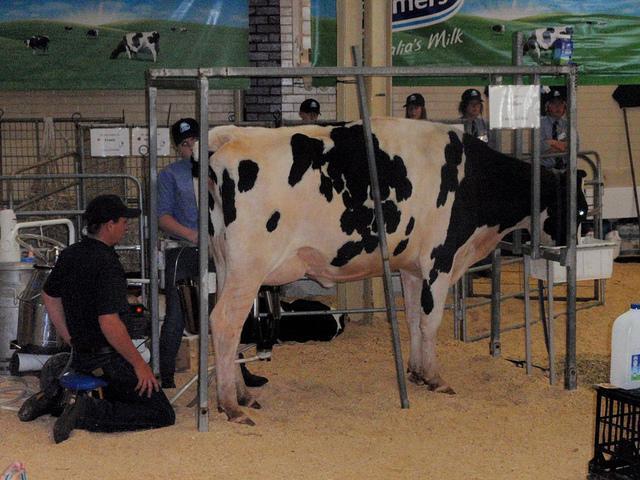How many cows are standing up?
Give a very brief answer. 1. How many cows are in the picture?
Give a very brief answer. 1. How many people are there?
Give a very brief answer. 3. 